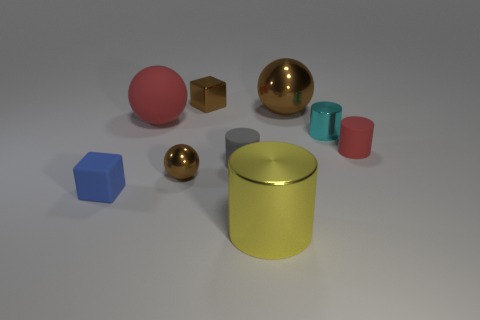Is there anything else that is the same size as the blue cube?
Offer a very short reply. Yes. There is a red object that is to the left of the red cylinder behind the large shiny cylinder; how big is it?
Provide a succinct answer. Large. The big cylinder has what color?
Your answer should be compact. Yellow. There is a large metallic thing that is in front of the tiny blue cube; what number of gray cylinders are behind it?
Provide a short and direct response. 1. There is a small cube that is in front of the large brown shiny ball; are there any small red objects left of it?
Provide a succinct answer. No. There is a large red sphere; are there any big metallic cylinders left of it?
Provide a succinct answer. No. Do the tiny thing in front of the small metal ball and the gray rubber thing have the same shape?
Your response must be concise. No. How many tiny brown shiny things have the same shape as the cyan metallic thing?
Offer a very short reply. 0. Are there any large gray objects made of the same material as the big red ball?
Keep it short and to the point. No. What material is the big object that is in front of the block in front of the small cyan thing made of?
Provide a short and direct response. Metal. 